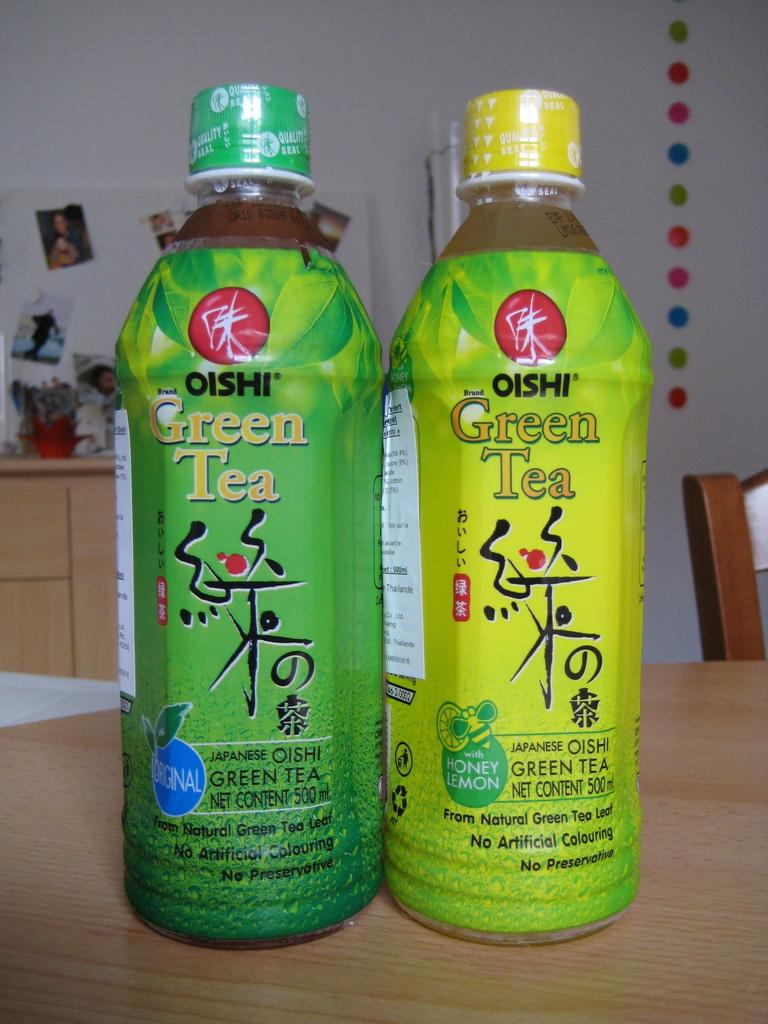<image>
Render a clear and concise summary of the photo. Two bottles of Oishi green tea sit side by side. 